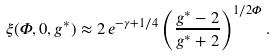Convert formula to latex. <formula><loc_0><loc_0><loc_500><loc_500>\xi ( \Phi , 0 , g ^ { * } ) \approx 2 \, e ^ { - \gamma + 1 / 4 } \left ( \frac { g ^ { * } - 2 } { g ^ { * } + 2 } \right ) ^ { 1 / 2 \Phi } .</formula> 